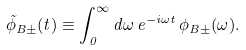Convert formula to latex. <formula><loc_0><loc_0><loc_500><loc_500>\tilde { \phi } _ { B \pm } ( t ) \equiv \int _ { 0 } ^ { \infty } d \omega \, e ^ { - i \omega t } \, \phi _ { B \pm } ( \omega ) .</formula> 